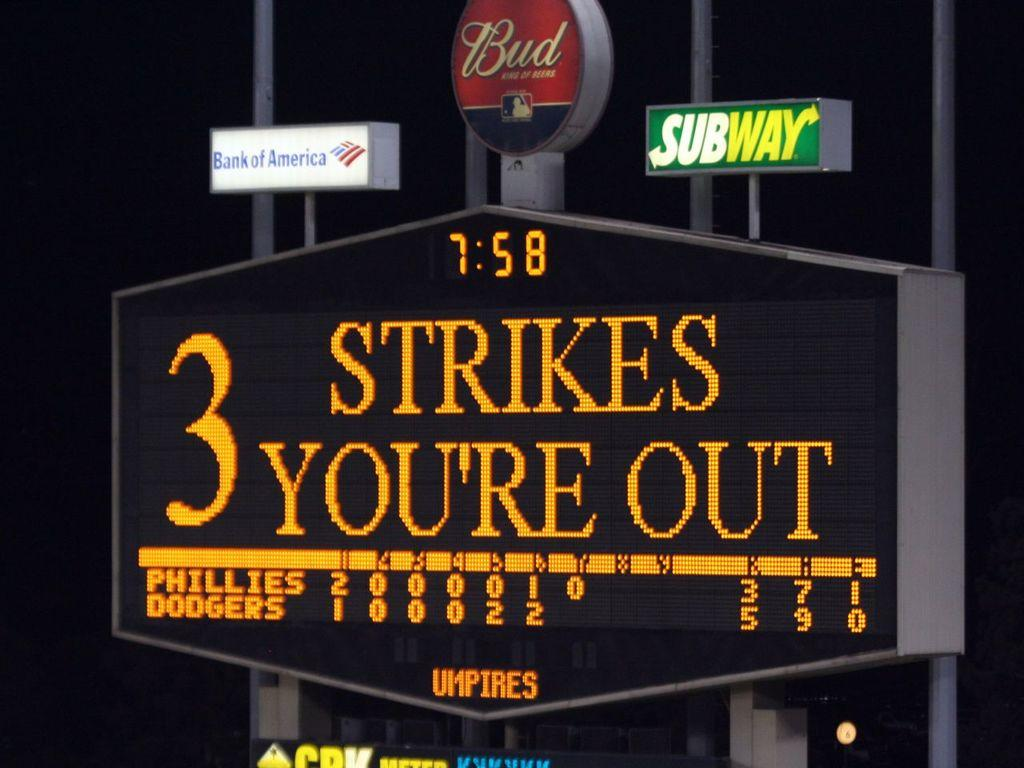<image>
Summarize the visual content of the image. A scoreboard displays the message "3 strikes you're out" 